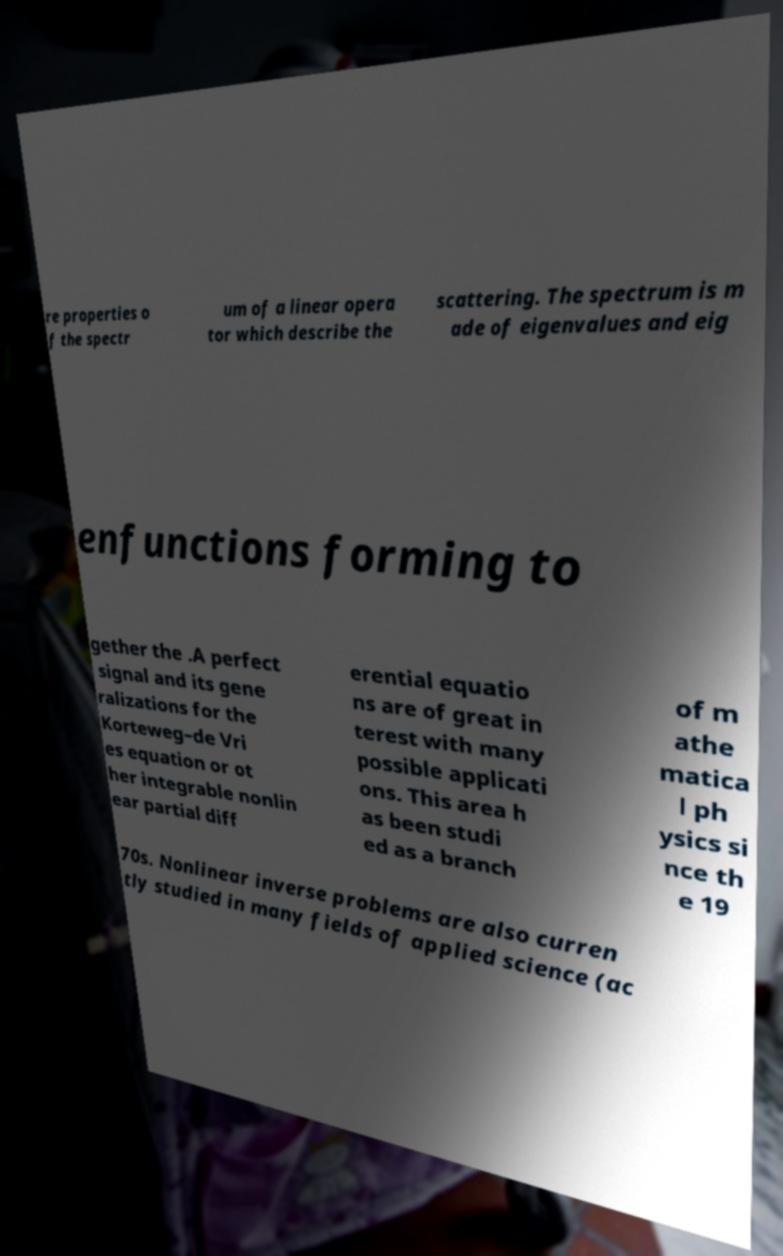For documentation purposes, I need the text within this image transcribed. Could you provide that? re properties o f the spectr um of a linear opera tor which describe the scattering. The spectrum is m ade of eigenvalues and eig enfunctions forming to gether the .A perfect signal and its gene ralizations for the Korteweg–de Vri es equation or ot her integrable nonlin ear partial diff erential equatio ns are of great in terest with many possible applicati ons. This area h as been studi ed as a branch of m athe matica l ph ysics si nce th e 19 70s. Nonlinear inverse problems are also curren tly studied in many fields of applied science (ac 